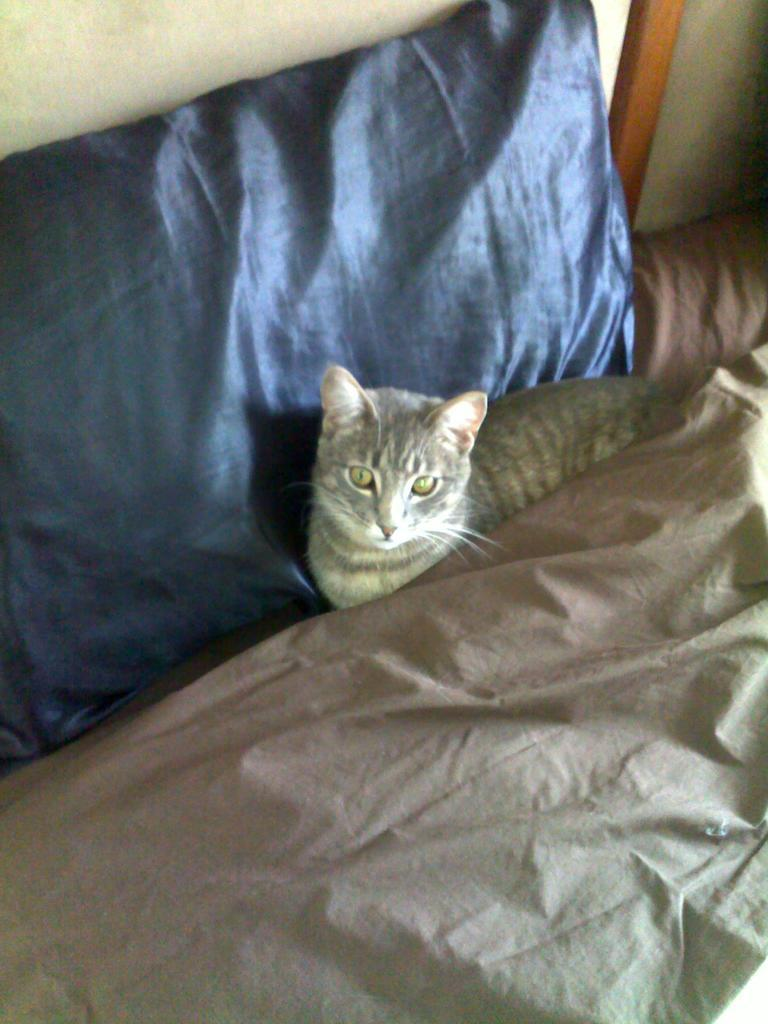What type of animal is on the bed in the image? There is a cat on the bed in the image. What is the cat resting on? The cat is resting on a pillow in the image. What else is on the bed besides the cat and pillow? There is a blanket on the bed in the image. What can be seen in the background of the image? There is a wall in the background of the image. What letters are being spelled out by the cat in the image? There are no letters present in the image, and the cat is not spelling out any words. 